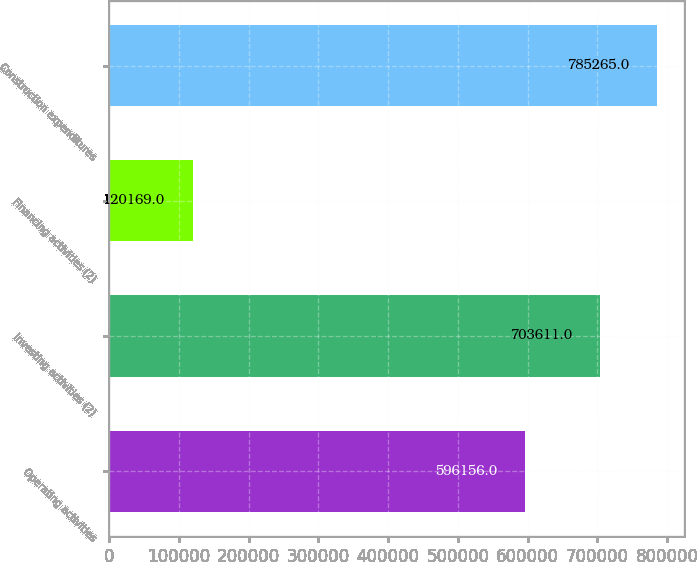Convert chart to OTSL. <chart><loc_0><loc_0><loc_500><loc_500><bar_chart><fcel>Operating activities<fcel>Investing activities (2)<fcel>Financing activities (2)<fcel>Construction expenditures<nl><fcel>596156<fcel>703611<fcel>120169<fcel>785265<nl></chart> 